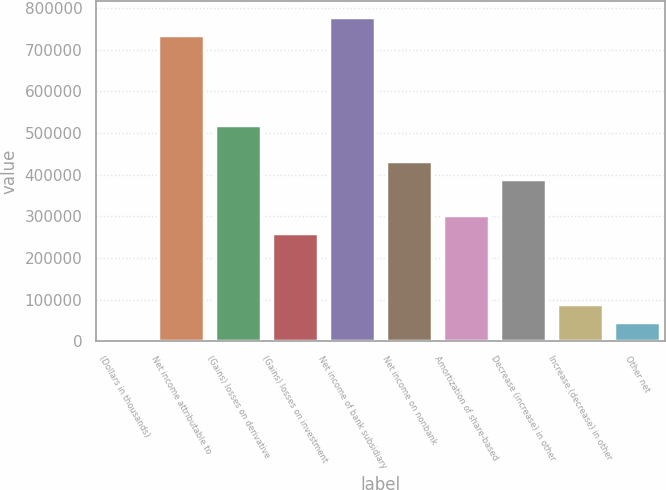Convert chart to OTSL. <chart><loc_0><loc_0><loc_500><loc_500><bar_chart><fcel>(Dollars in thousands)<fcel>Net income attributable to<fcel>(Gains) losses on derivative<fcel>(Gains) losses on investment<fcel>Net income of bank subsidiary<fcel>Net income on nonbank<fcel>Amortization of share-based<fcel>Decrease (increase) in other<fcel>Increase (decrease) in other<fcel>Other net<nl><fcel>2011<fcel>735816<fcel>519991<fcel>261001<fcel>778981<fcel>433661<fcel>304166<fcel>390496<fcel>88341<fcel>45176<nl></chart> 